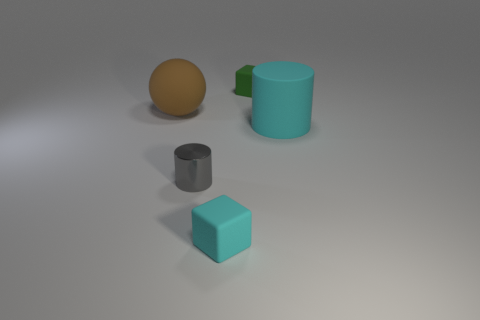How many other things are there of the same material as the gray thing?
Offer a terse response. 0. There is a large matte thing on the left side of the large cylinder; does it have the same shape as the metal object?
Give a very brief answer. No. What is the material of the large cyan object that is the same shape as the gray shiny object?
Keep it short and to the point. Rubber. Is there a metallic cylinder?
Give a very brief answer. Yes. There is a cyan thing that is to the right of the matte cube that is on the right side of the cyan matte object that is in front of the small gray shiny thing; what is its material?
Your answer should be very brief. Rubber. Does the small gray metallic thing have the same shape as the big thing in front of the matte ball?
Ensure brevity in your answer.  Yes. How many green rubber things have the same shape as the big brown matte object?
Your answer should be very brief. 0. There is a small metallic object; what shape is it?
Your answer should be compact. Cylinder. What is the size of the cyan matte thing that is behind the metallic object that is in front of the big brown rubber thing?
Provide a short and direct response. Large. How many objects are cyan cylinders or red metal blocks?
Provide a succinct answer. 1. 